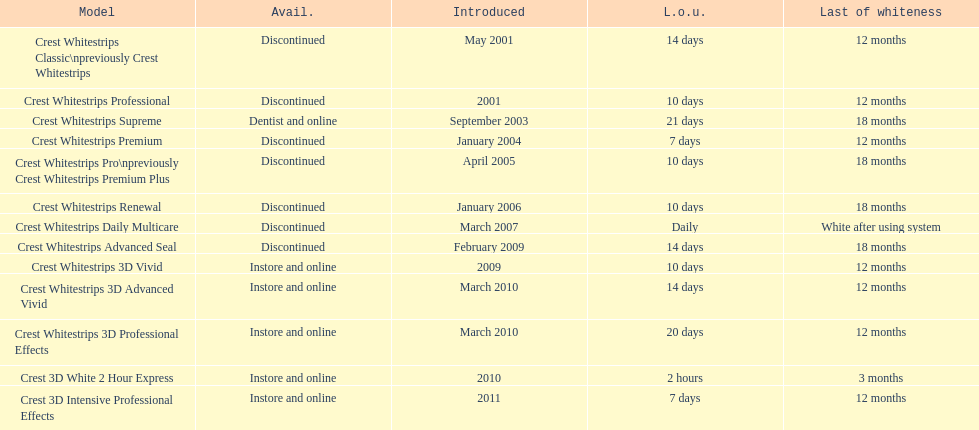What products are listed? Crest Whitestrips Classic\npreviously Crest Whitestrips, Crest Whitestrips Professional, Crest Whitestrips Supreme, Crest Whitestrips Premium, Crest Whitestrips Pro\npreviously Crest Whitestrips Premium Plus, Crest Whitestrips Renewal, Crest Whitestrips Daily Multicare, Crest Whitestrips Advanced Seal, Crest Whitestrips 3D Vivid, Crest Whitestrips 3D Advanced Vivid, Crest Whitestrips 3D Professional Effects, Crest 3D White 2 Hour Express, Crest 3D Intensive Professional Effects. Of these, which was were introduced in march, 2010? Crest Whitestrips 3D Advanced Vivid, Crest Whitestrips 3D Professional Effects. Of these, which were not 3d advanced vivid? Crest Whitestrips 3D Professional Effects. 